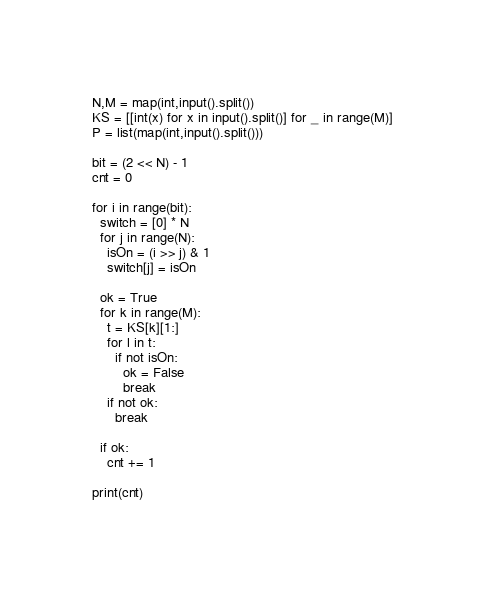<code> <loc_0><loc_0><loc_500><loc_500><_Python_>N,M = map(int,input().split())
KS = [[int(x) for x in input().split()] for _ in range(M)]
P = list(map(int,input().split()))

bit = (2 << N) - 1
cnt = 0

for i in range(bit):
  switch = [0] * N
  for j in range(N):
    isOn = (i >> j) & 1
    switch[j] = isOn

  ok = True
  for k in range(M):
    t = KS[k][1:]
    for l in t:
      if not isOn:
        ok = False
        break
    if not ok:
      break

  if ok:
    cnt += 1
    
print(cnt)</code> 